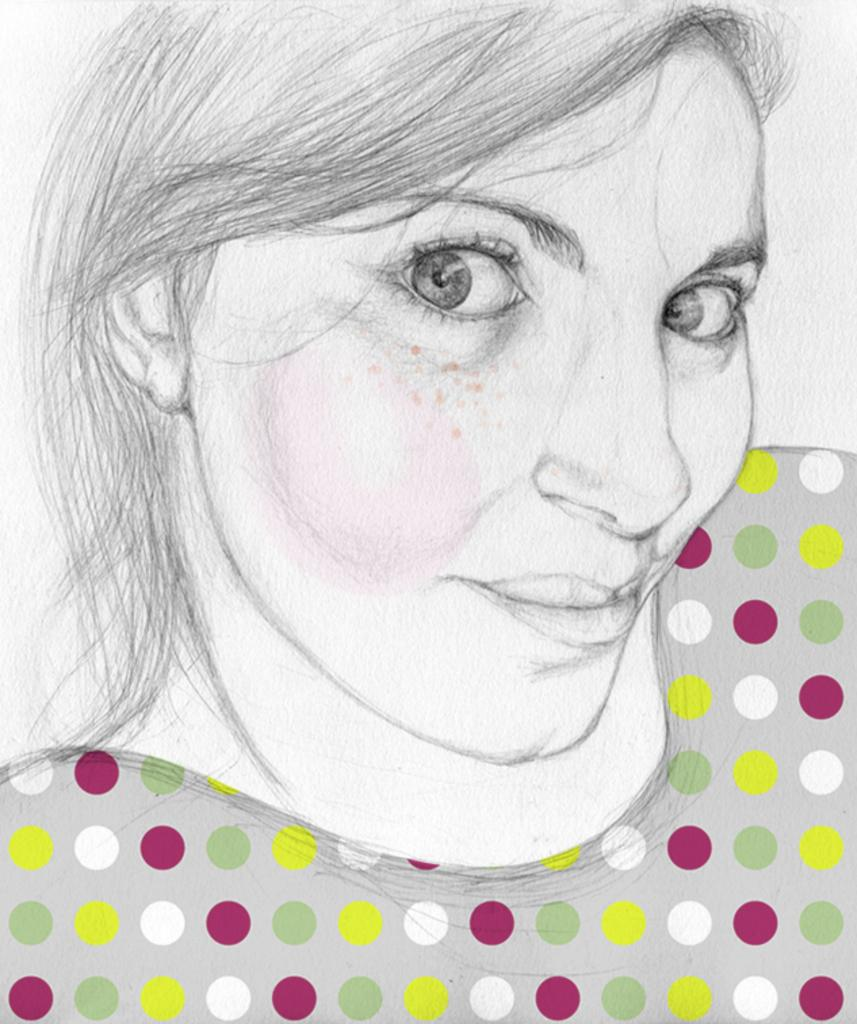What type of art is featured in the image? The image is a pencil art. What subject is depicted in the pencil art? The pencil art depicts a woman. What type of lace is used to create the woman's dress in the image? There is no mention of lace or a dress in the image, as it is a pencil art depicting a woman. What type of rock is visible in the background of the image? There is no rock visible in the image, as it is a pencil art depicting a woman. 